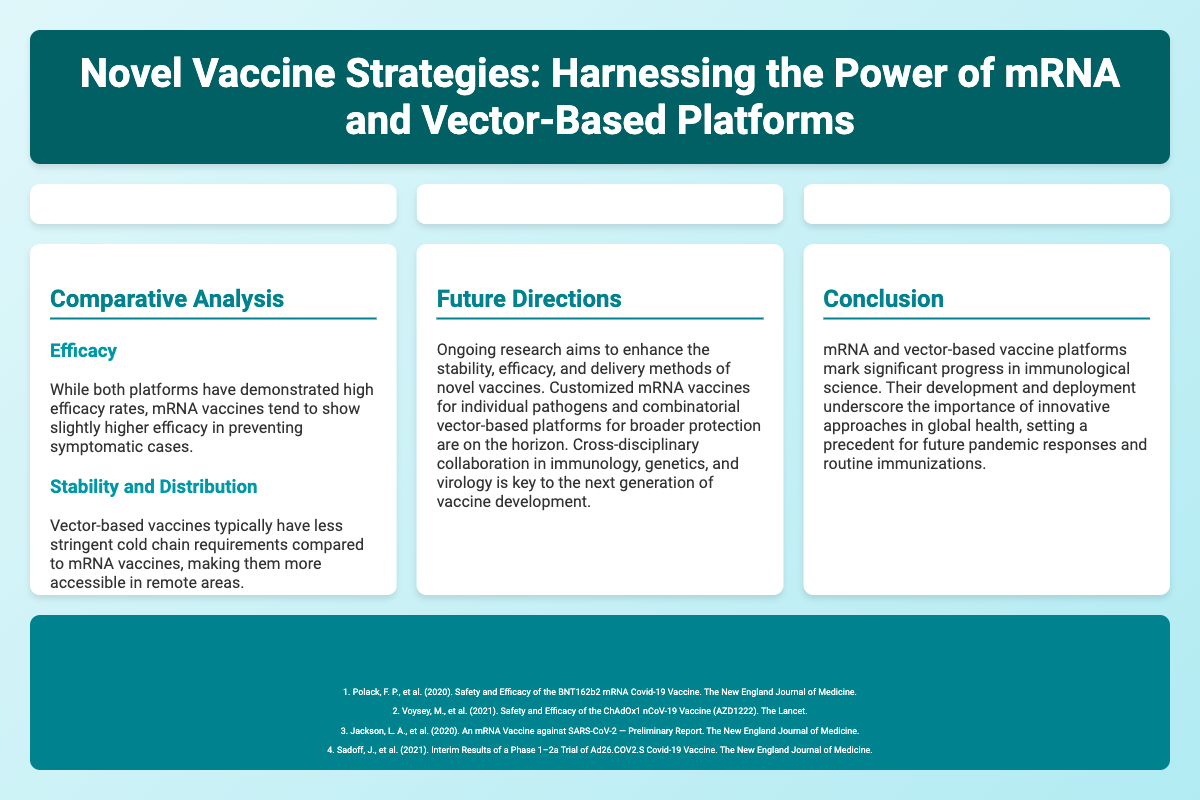what are the two novel vaccine platforms discussed? The poster mentions mRNA and vector-based vaccines as the two novel vaccine platforms.
Answer: mRNA and vector-based vaccines what is an example of an mRNA vaccine? The poster provides examples of mRNA vaccines, specifically named.
Answer: Pfizer-BioNTech (BNT162b2) what advantage of mRNA vaccines is highlighted? The poster states that mRNA vaccines offer rapid development and production as an advantage.
Answer: Rapid development and production what mechanism do vector-based vaccines use? The document describes how vector-based vaccines use engineered viruses to deliver genetic material.
Answer: Use a different virus (the vector) what is one of the future directions in vaccine research mentioned? The poster discusses ongoing research directions, including customized mRNA vaccines.
Answer: Customized mRNA vaccines which vaccine is associated with Johnson & Johnson? The document lists a specific vaccine associated with Johnson & Johnson as an example.
Answer: Ad26.COV2.S how do mRNA vaccines and vector-based vaccines compare in terms of efficacy? The poster indicates that mRNA vaccines tend to show slightly higher efficacy rates.
Answer: Slightly higher efficacy what is the significance of cross-disciplinary collaboration? The poster emphasizes that collaboration across fields is key to future vaccine development.
Answer: Key to the next generation of vaccine development what color is used in the poster’s header? The document specifies the color of the header background in the visual style.
Answer: #006064 